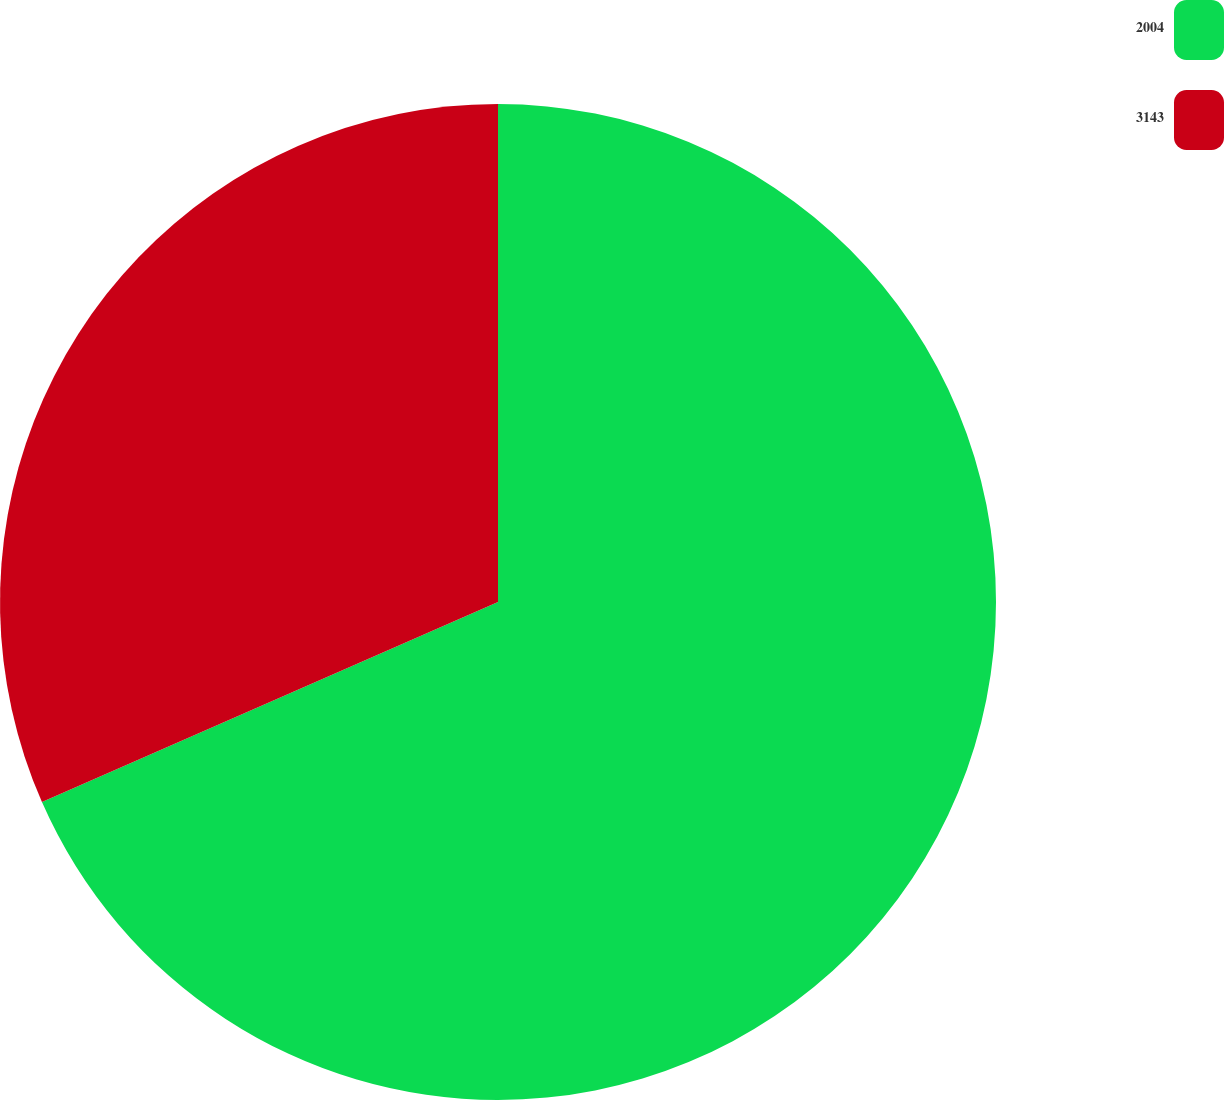<chart> <loc_0><loc_0><loc_500><loc_500><pie_chart><fcel>2004<fcel>3143<nl><fcel>68.42%<fcel>31.58%<nl></chart> 